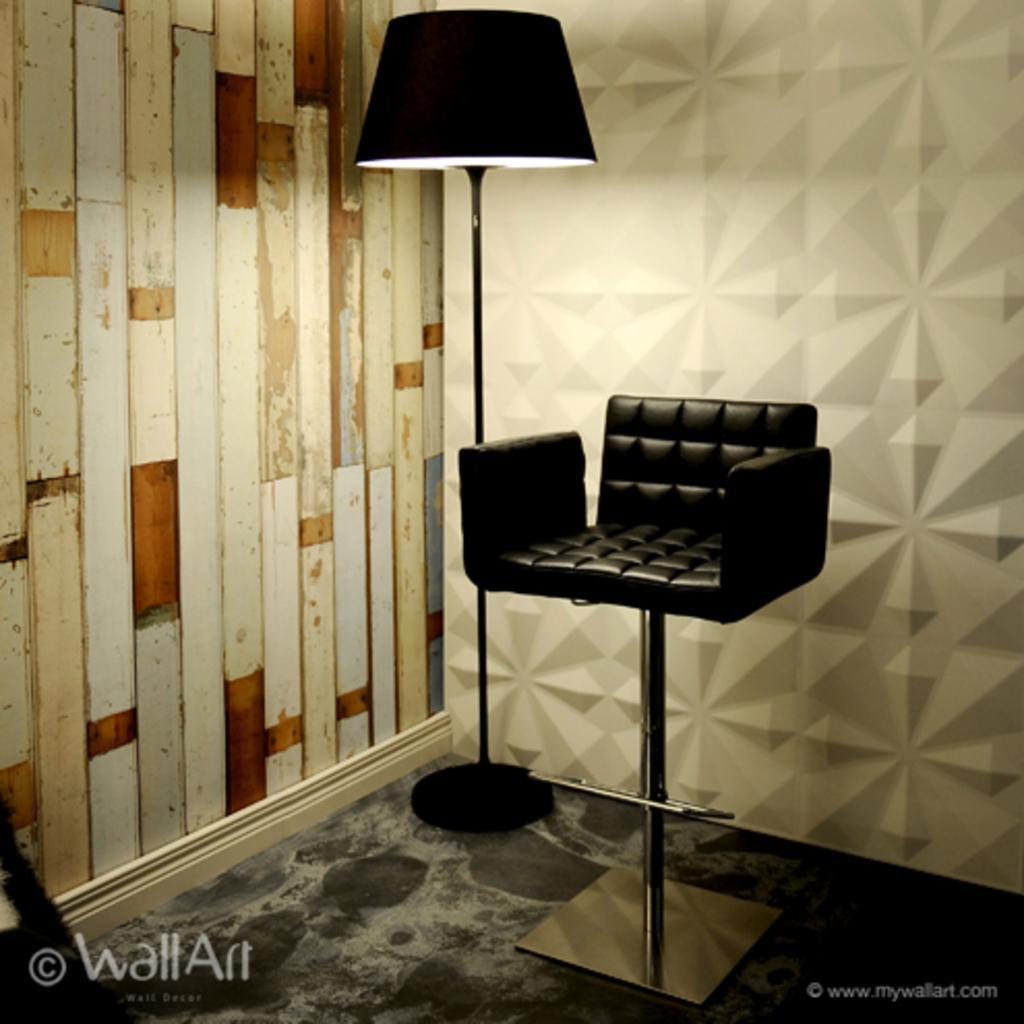Please provide a concise description of this image. In this picture we can see a chair and a lamp in the middle, on the left side there is a wall, at the right bottom there is some text, we can see a wall art in the background. 